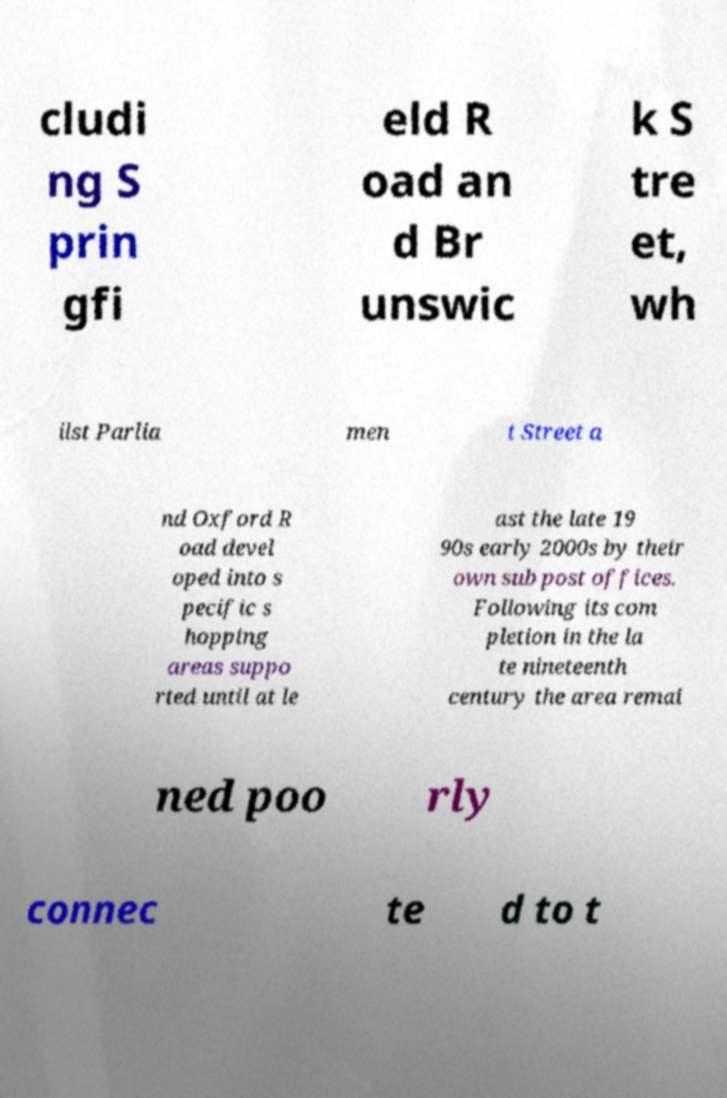What messages or text are displayed in this image? I need them in a readable, typed format. cludi ng S prin gfi eld R oad an d Br unswic k S tre et, wh ilst Parlia men t Street a nd Oxford R oad devel oped into s pecific s hopping areas suppo rted until at le ast the late 19 90s early 2000s by their own sub post offices. Following its com pletion in the la te nineteenth century the area remai ned poo rly connec te d to t 